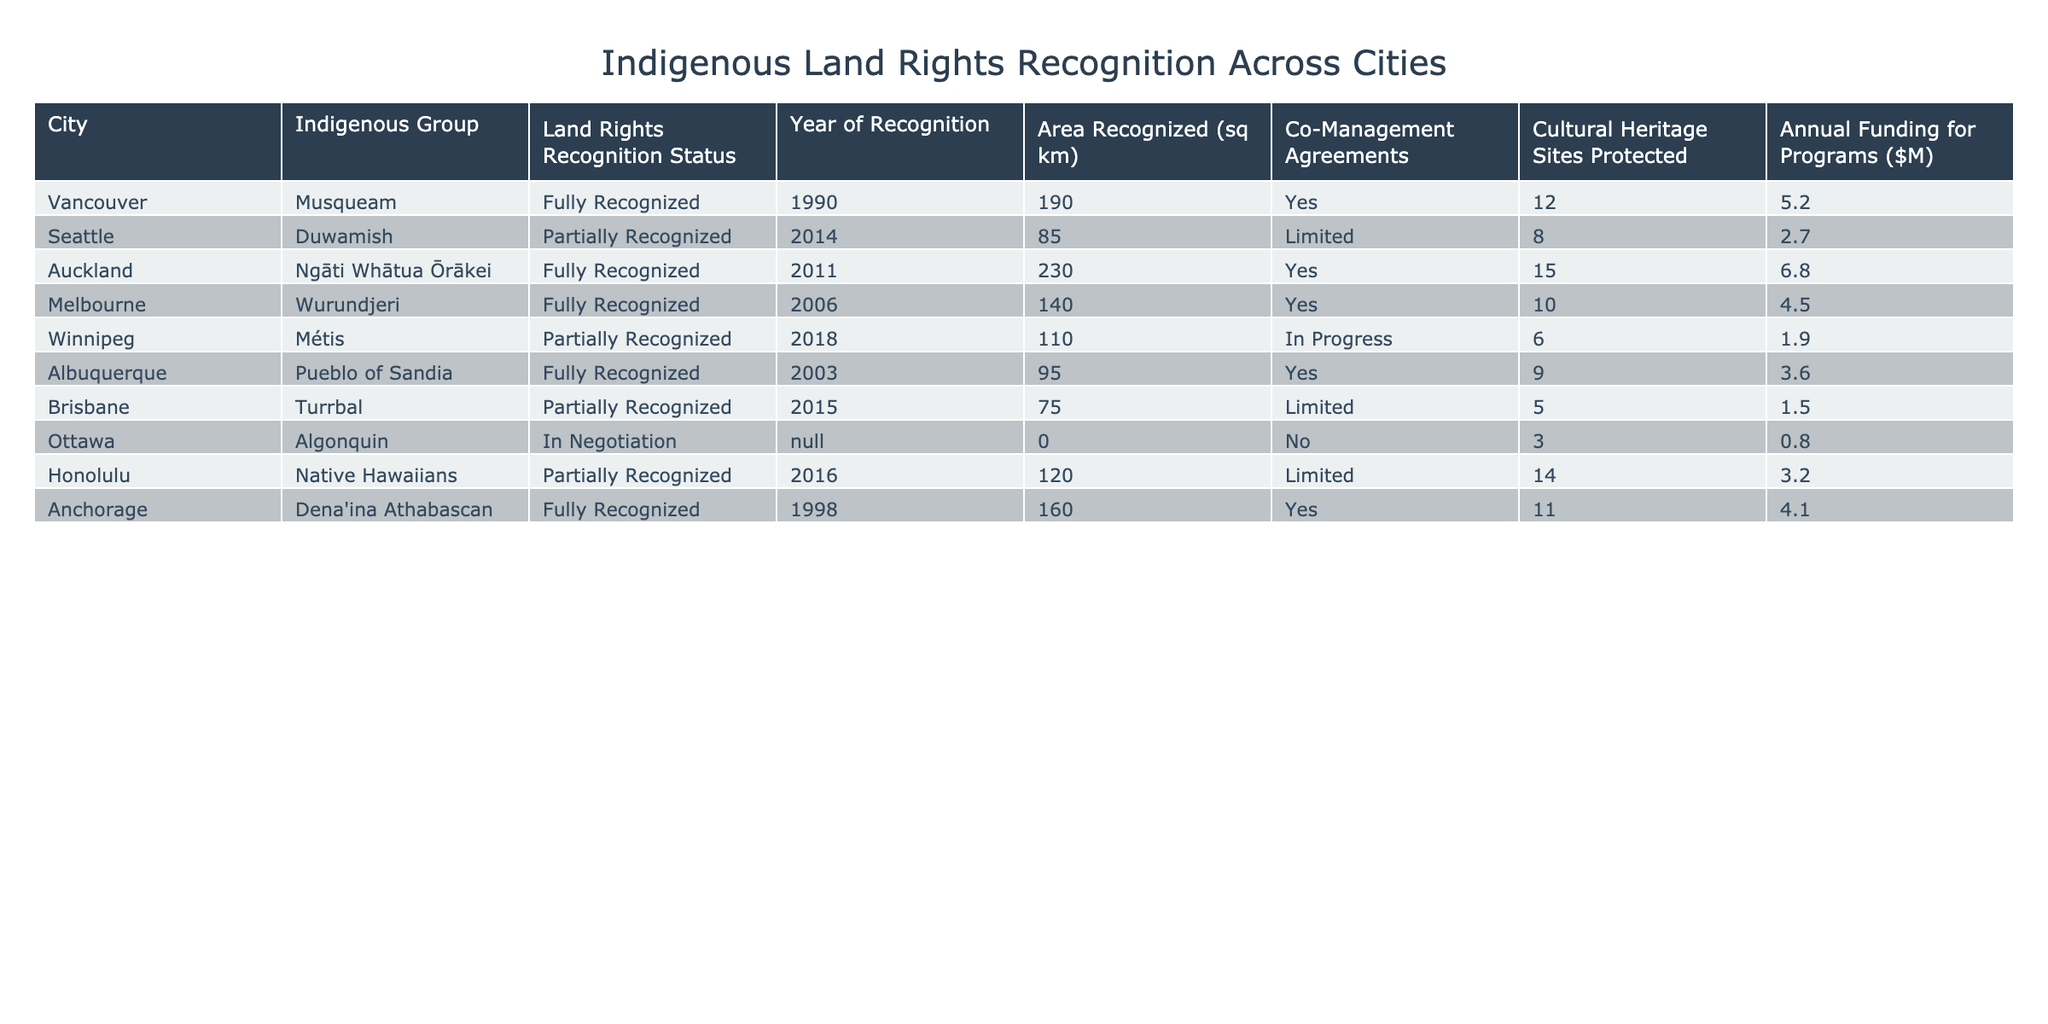What is the land rights recognition status for the Duwamish in Seattle? According to the table, the status listed for the Duwamish is "Partially Recognized."
Answer: Partially Recognized Which city has the largest area recognized for indigenous land rights? From the table, Auckland has the largest area recognized at 230 square kilometers.
Answer: Auckland, 230 sq km How many cultural heritage sites are protected for the Musqueam in Vancouver? The table indicates that 12 cultural heritage sites are protected for the Musqueam.
Answer: 12 Is there a co-management agreement in place for the Algonquin in Ottawa? The table shows "No" under co-management agreements for the Algonquin.
Answer: No What is the average area recognized for all cities that have fully recognized land rights? The area recognized for fully recognized cities is summed up (190 + 230 + 140 + 95 + 160) = 815 square kilometers. There are 5 cities, so the average is 815/5 = 163 square kilometers.
Answer: 163 sq km Which indigenous group has the highest annual funding for programs and how much is it? By reviewing the table, Ngāti Whātua Ōrākei in Auckland has the highest annual funding amounting to $6.8 million.
Answer: Ngāti Whātua Ōrākei, $6.8M How many cities have a fully recognized land rights status? The table lists 5 cities with fully recognized land rights status: Vancouver, Auckland, Melbourne, Albuquerque, and Anchorage.
Answer: 5 What percentage of cities listed have a co-management agreement in place? There are 8 cities in total. 5 of them have co-management agreements (Vancouver, Auckland, Melbourne, Albuquerque, and Anchorage). The percentage is (5/8) * 100 = 62.5%.
Answer: 62.5% Which two cities have a partially recognized status but are still providing cultural heritage site protection, and how many sites are protected in each? The cities with partially recognized status that provide cultural heritage site protection are Honolulu (14 sites) and Seattle (8 sites).
Answer: Honolulu (14), Seattle (8) 